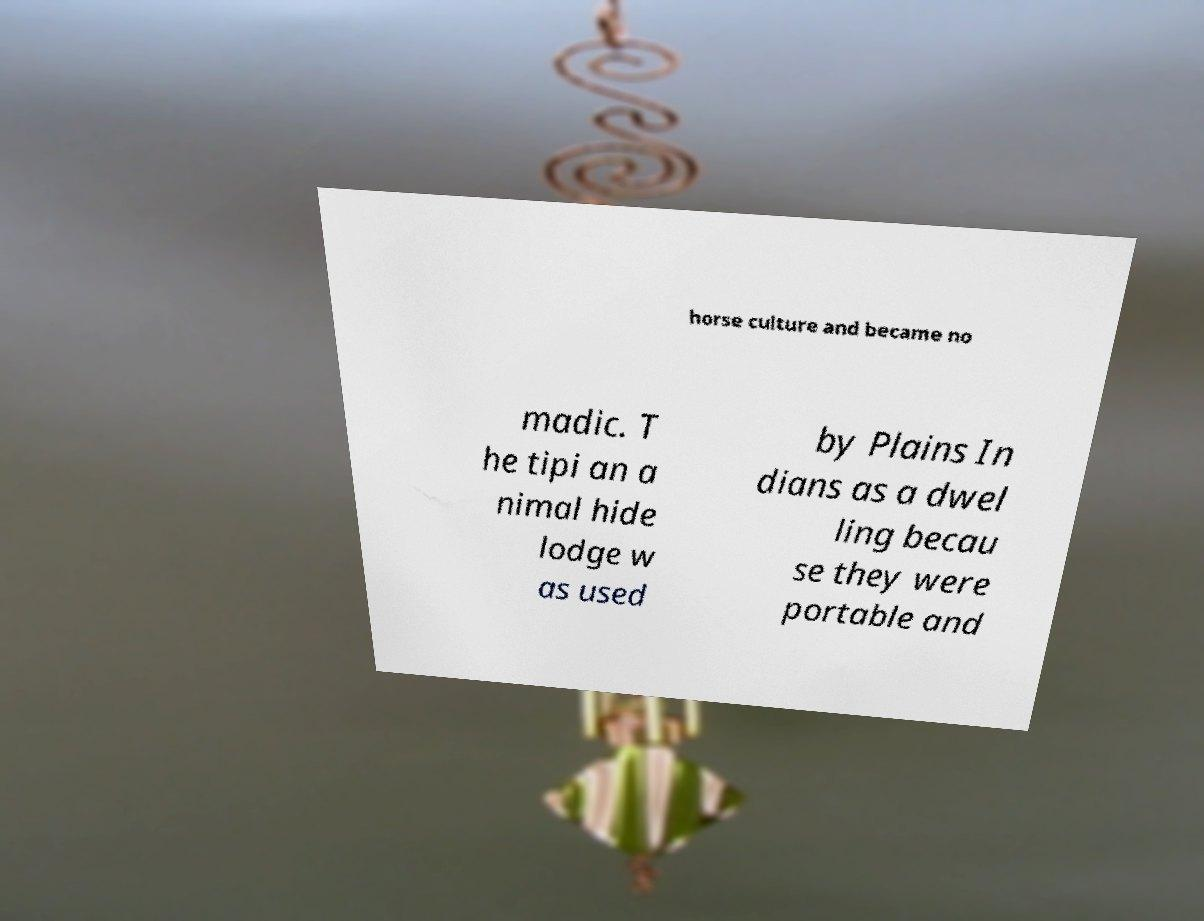Can you read and provide the text displayed in the image?This photo seems to have some interesting text. Can you extract and type it out for me? horse culture and became no madic. T he tipi an a nimal hide lodge w as used by Plains In dians as a dwel ling becau se they were portable and 